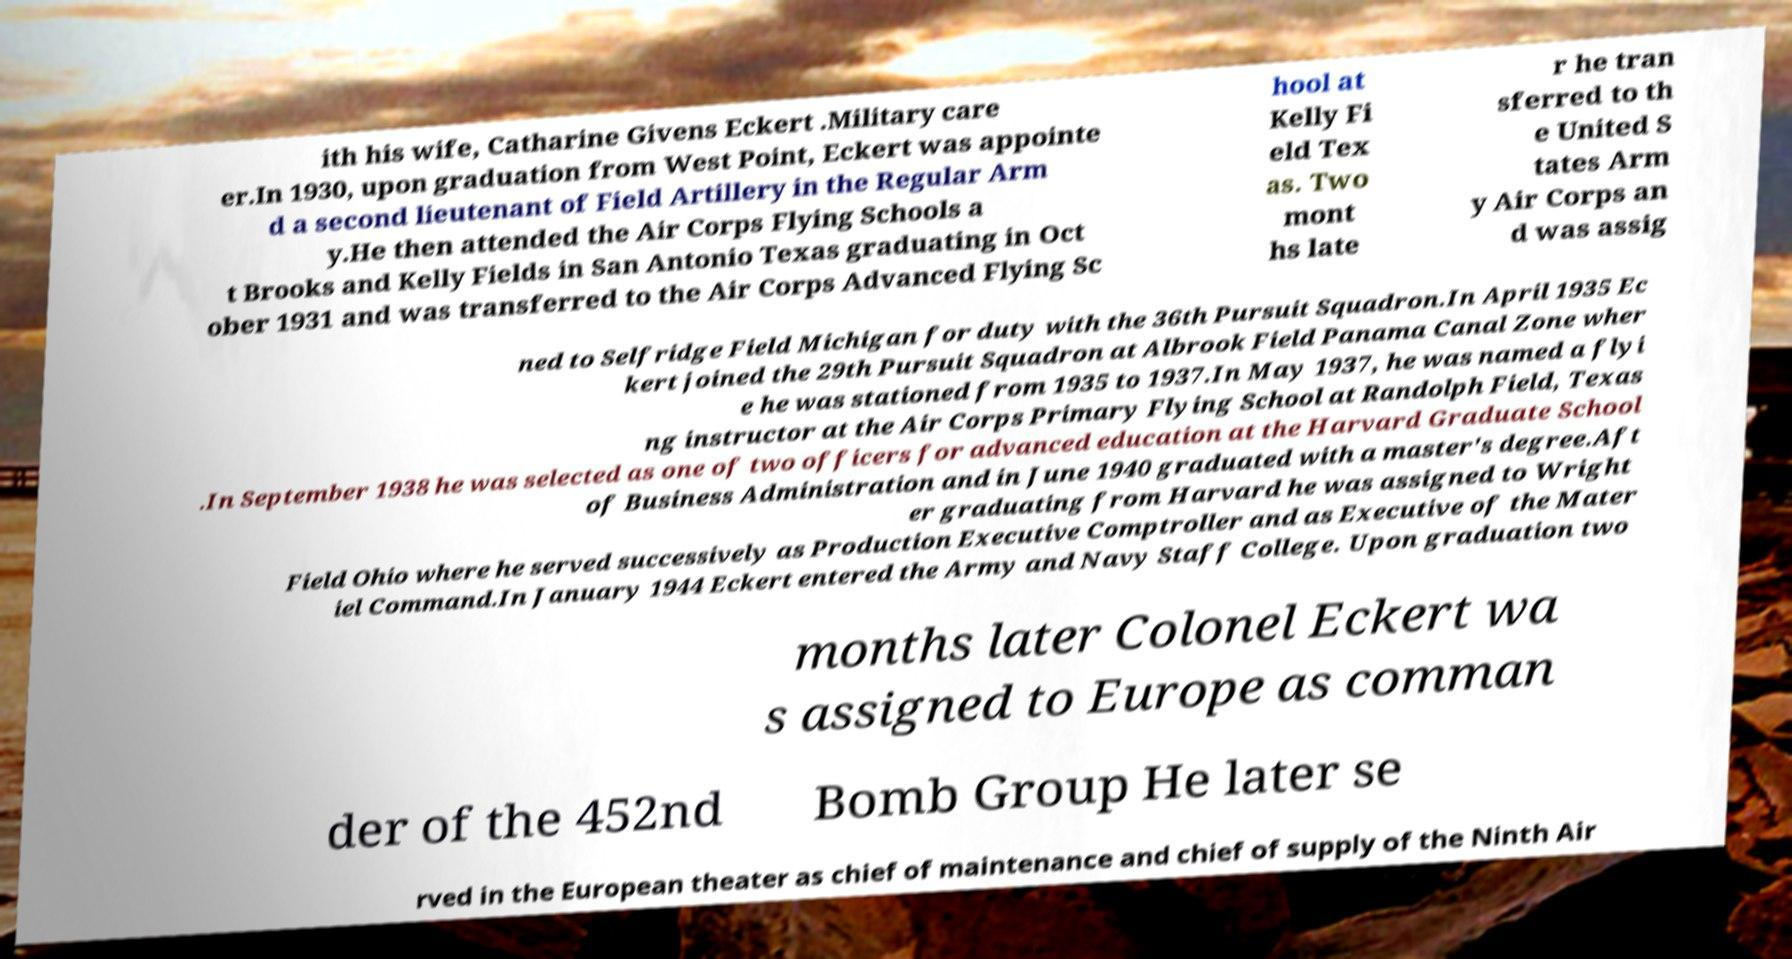What messages or text are displayed in this image? I need them in a readable, typed format. ith his wife, Catharine Givens Eckert .Military care er.In 1930, upon graduation from West Point, Eckert was appointe d a second lieutenant of Field Artillery in the Regular Arm y.He then attended the Air Corps Flying Schools a t Brooks and Kelly Fields in San Antonio Texas graduating in Oct ober 1931 and was transferred to the Air Corps Advanced Flying Sc hool at Kelly Fi eld Tex as. Two mont hs late r he tran sferred to th e United S tates Arm y Air Corps an d was assig ned to Selfridge Field Michigan for duty with the 36th Pursuit Squadron.In April 1935 Ec kert joined the 29th Pursuit Squadron at Albrook Field Panama Canal Zone wher e he was stationed from 1935 to 1937.In May 1937, he was named a flyi ng instructor at the Air Corps Primary Flying School at Randolph Field, Texas .In September 1938 he was selected as one of two officers for advanced education at the Harvard Graduate School of Business Administration and in June 1940 graduated with a master's degree.Aft er graduating from Harvard he was assigned to Wright Field Ohio where he served successively as Production Executive Comptroller and as Executive of the Mater iel Command.In January 1944 Eckert entered the Army and Navy Staff College. Upon graduation two months later Colonel Eckert wa s assigned to Europe as comman der of the 452nd Bomb Group He later se rved in the European theater as chief of maintenance and chief of supply of the Ninth Air 